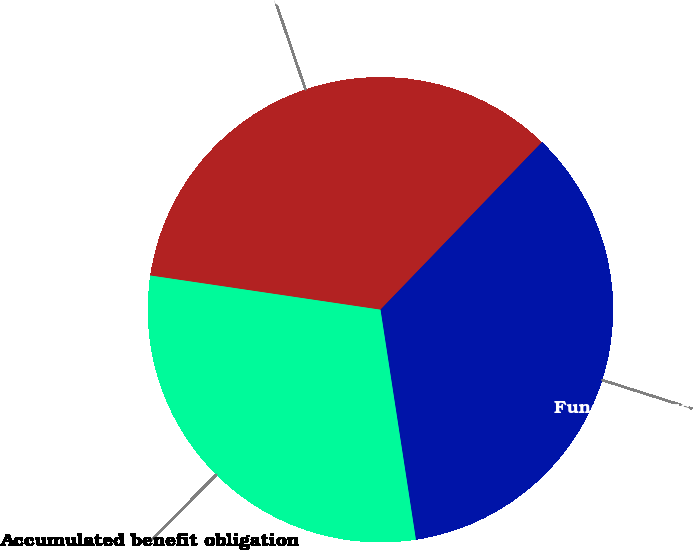<chart> <loc_0><loc_0><loc_500><loc_500><pie_chart><fcel>Projected benefit obligation<fcel>Funded status at end of year<fcel>Accumulated benefit obligation<nl><fcel>34.86%<fcel>35.36%<fcel>29.78%<nl></chart> 